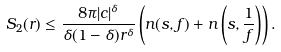Convert formula to latex. <formula><loc_0><loc_0><loc_500><loc_500>S _ { 2 } ( r ) & \leq \frac { 8 \pi | c | ^ { \delta } } { \delta ( 1 - \delta ) r ^ { \delta } } \left ( n ( s , f ) + n \left ( s , \frac { 1 } { f } \right ) \right ) .</formula> 